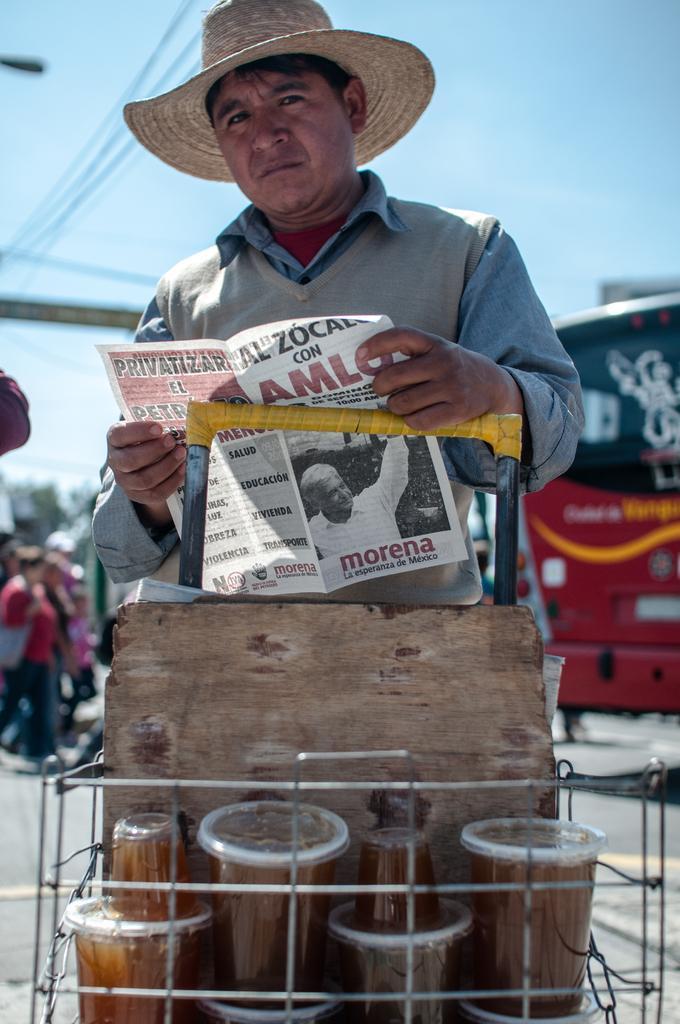Can you describe this image briefly? This is the man standing and holding a paper in his hands. He wore a hat, shirt and sweater. This looks like a wheel cart with few objects in it. In the background, that looks like a bus and there are few people walking. 